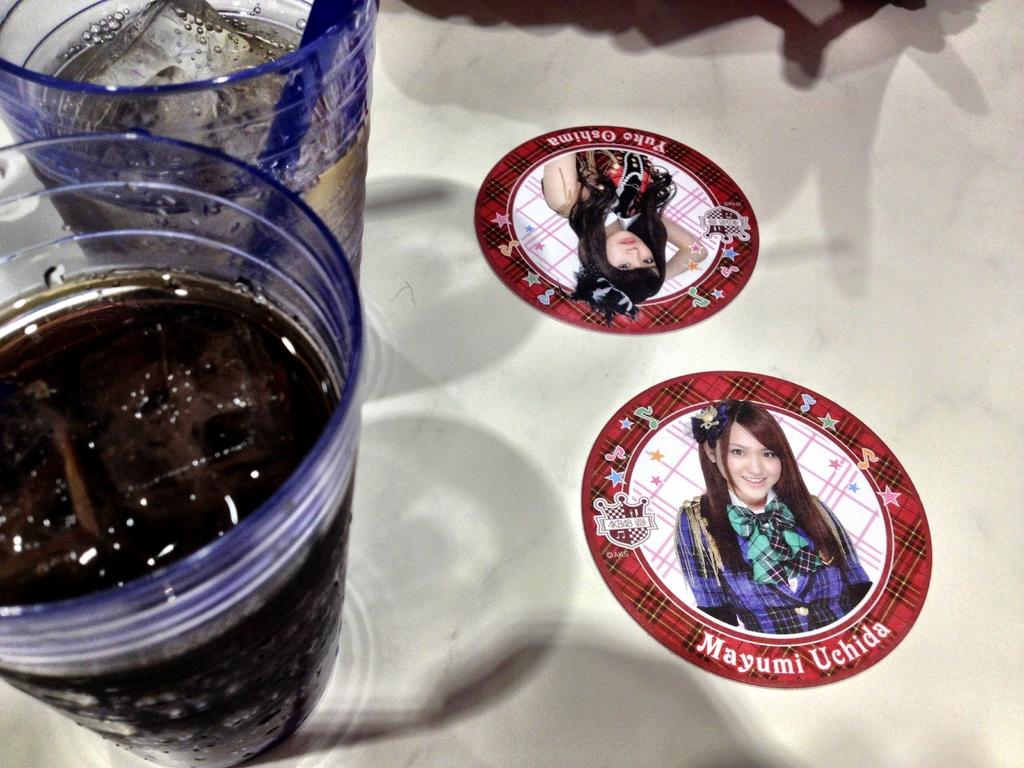What objects are on the surface in the image? There are glasses on a surface in the image. What is inside the glasses? There are ice cubes and a drink in the glasses. What is located to the right of the glasses? There are stickers to the right of the glasses. What is depicted on the stickers? The stickers have pictures of a woman. What else can be seen on the stickers? The stickers have text on them. Can you see a monkey swinging from the ceiling in the image? No, there is no monkey present in the image. Is the drink in the glasses related to space exploration? There is no indication in the image that the drink is related to space exploration. 